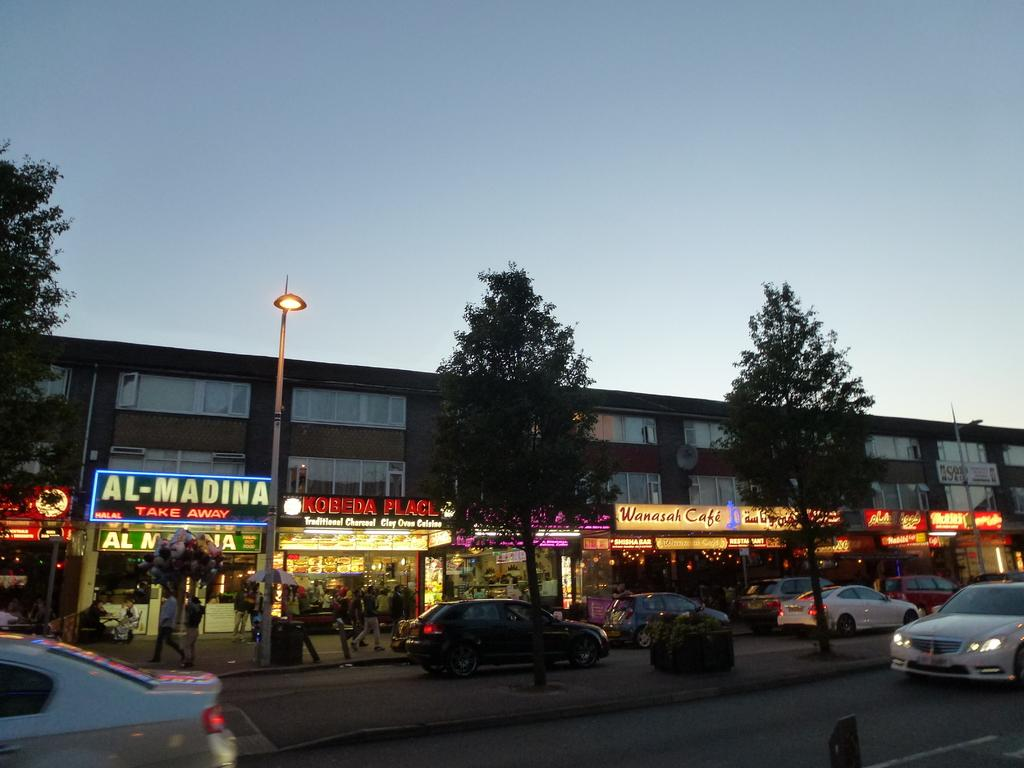What type of structure can be seen in the image? There is a building in the image. What natural elements are present in the image? There are trees and grass visible in the image. What type of transportation is present in the image? Vehicles are present on the roads in the image. What type of lighting is visible in the image? Pole lights are visible in the image. What type of electronic signage is present in the image? LED boards are in the image. What other objects can be seen on the ground in the image? There are other objects on the ground in the image. What can be seen in the background of the image? The sky is visible in the background of the image. What type of coil is used for the treatment of the trees in the image? There is no mention of any treatment or coil in the image; it features a building, trees, vehicles, pole lights, LED boards, and other objects on the ground, with the sky visible in the background. 